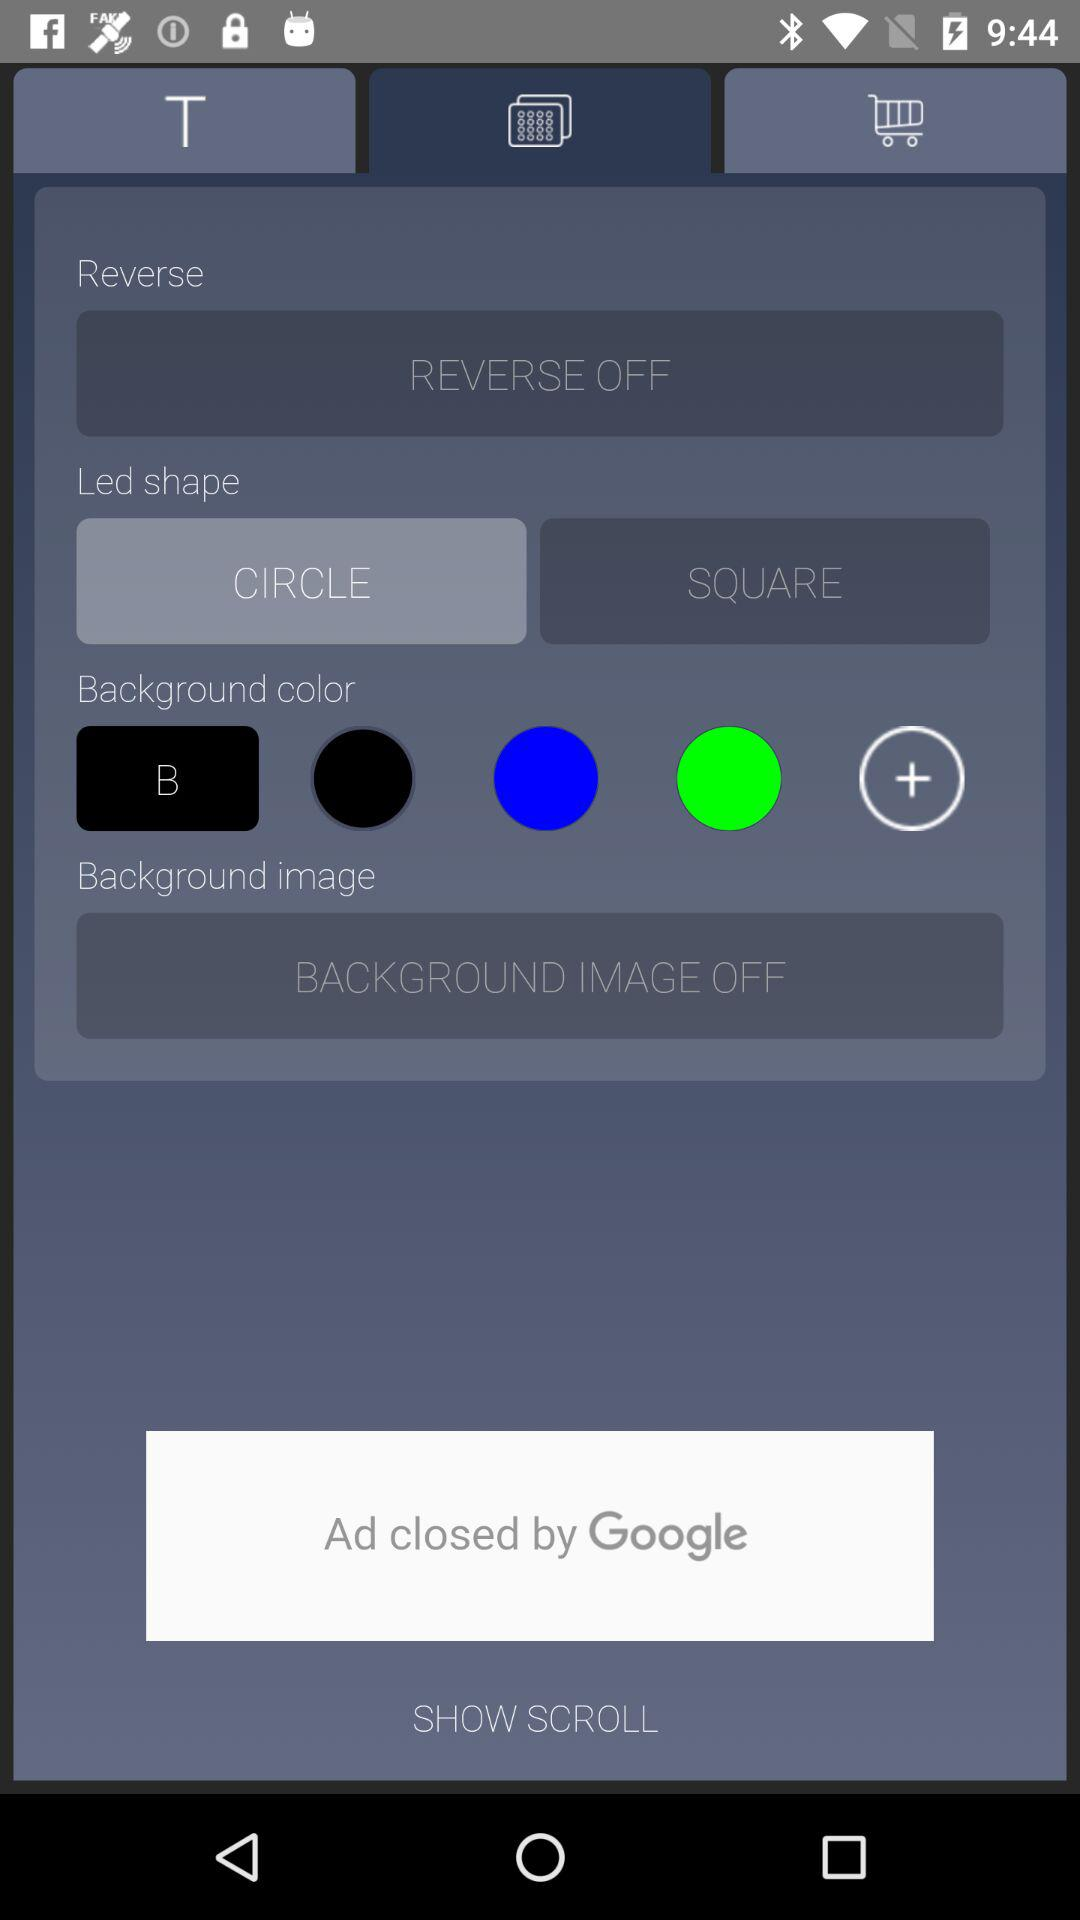What's the selected led shape? The selected led shape is circle. 